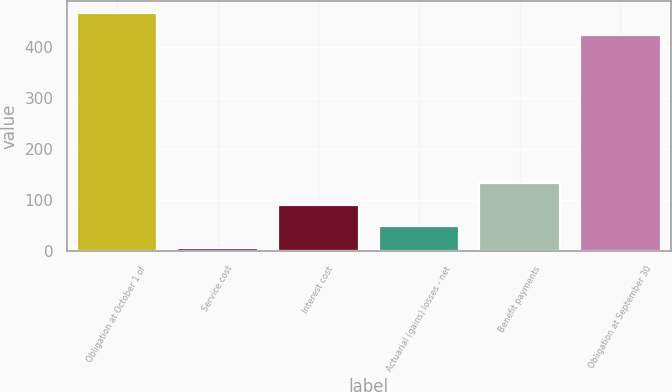<chart> <loc_0><loc_0><loc_500><loc_500><bar_chart><fcel>Obligation at October 1 of<fcel>Service cost<fcel>Interest cost<fcel>Actuarial (gains) losses - net<fcel>Benefit payments<fcel>Obligation at September 30<nl><fcel>467.9<fcel>6<fcel>91.8<fcel>48.9<fcel>134.7<fcel>425<nl></chart> 